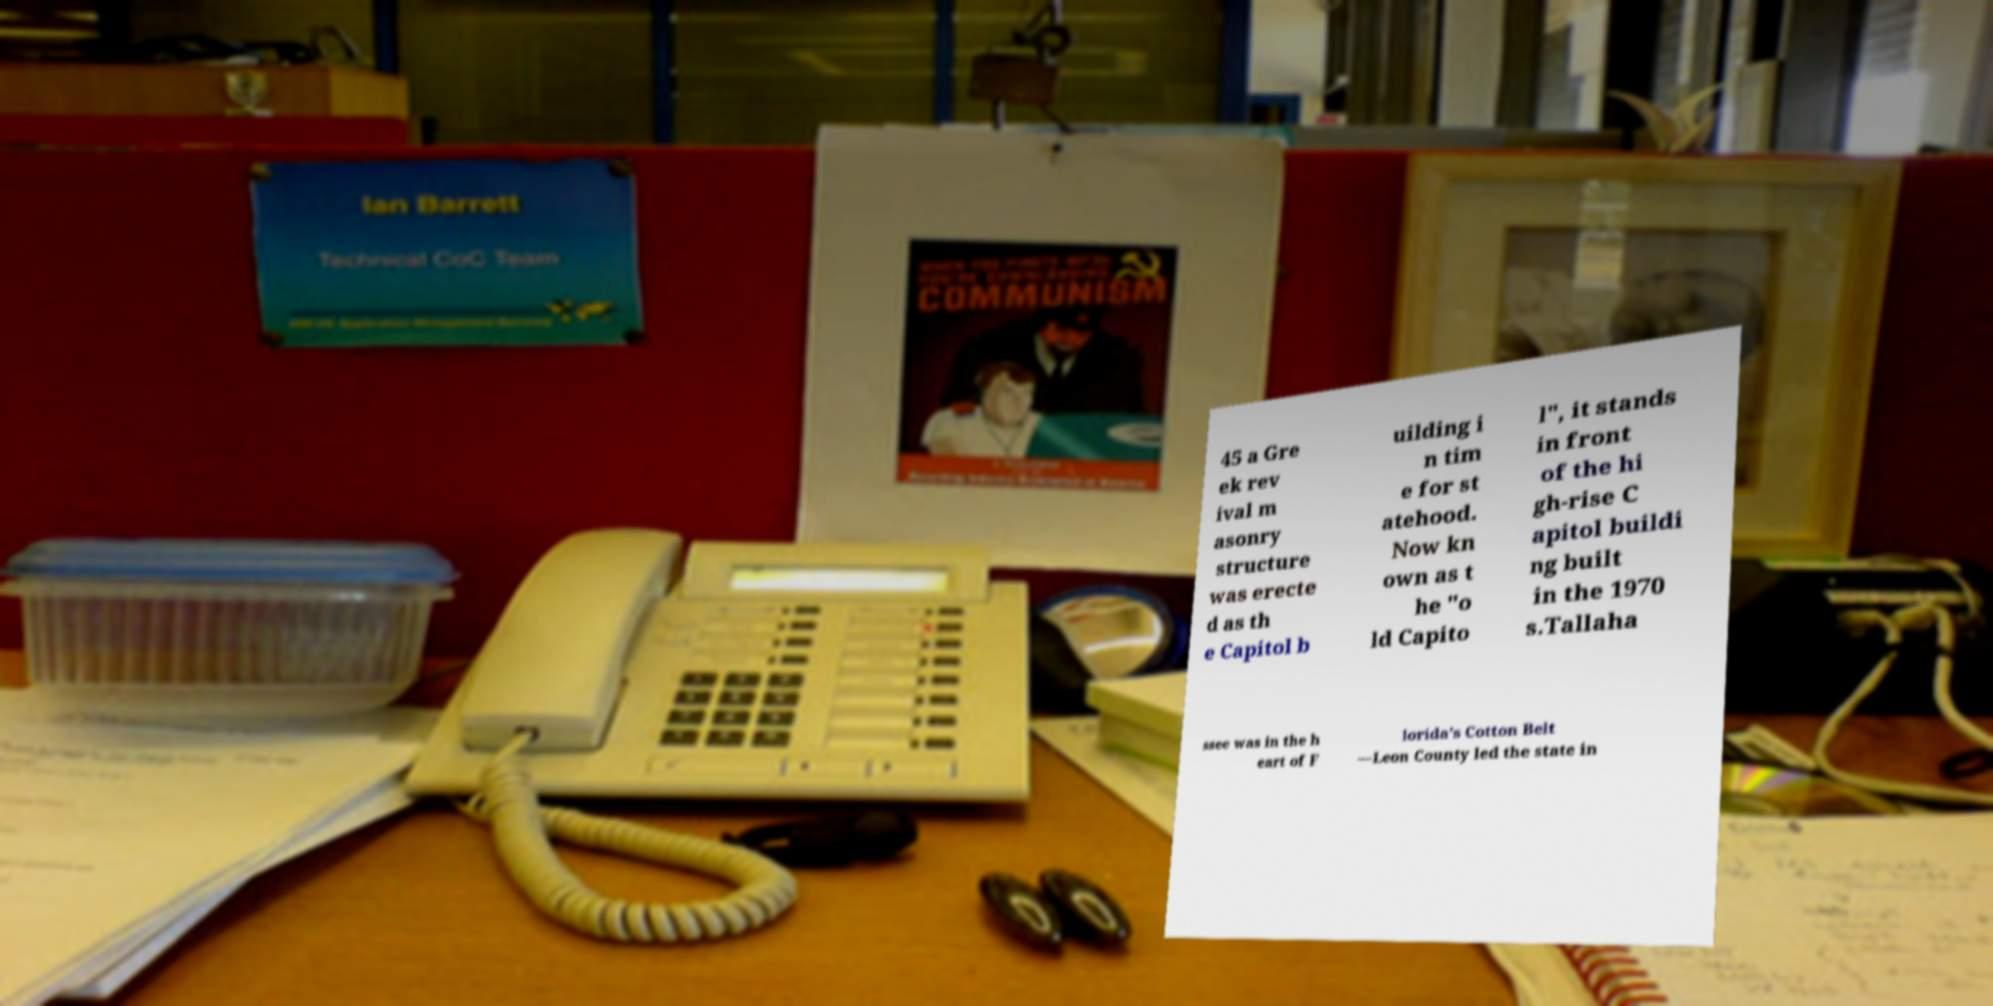Can you read and provide the text displayed in the image?This photo seems to have some interesting text. Can you extract and type it out for me? 45 a Gre ek rev ival m asonry structure was erecte d as th e Capitol b uilding i n tim e for st atehood. Now kn own as t he "o ld Capito l", it stands in front of the hi gh-rise C apitol buildi ng built in the 1970 s.Tallaha ssee was in the h eart of F lorida's Cotton Belt —Leon County led the state in 